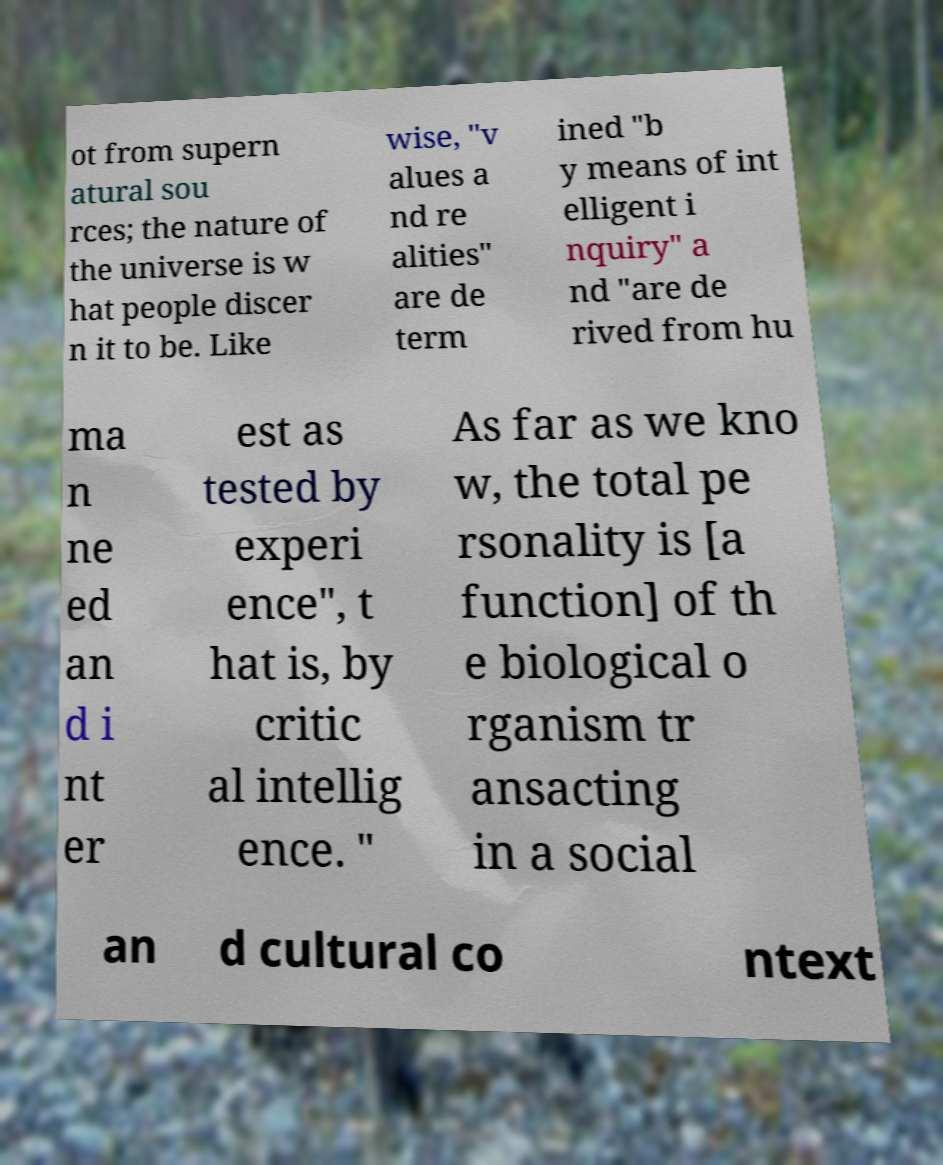What messages or text are displayed in this image? I need them in a readable, typed format. ot from supern atural sou rces; the nature of the universe is w hat people discer n it to be. Like wise, "v alues a nd re alities" are de term ined "b y means of int elligent i nquiry" a nd "are de rived from hu ma n ne ed an d i nt er est as tested by experi ence", t hat is, by critic al intellig ence. " As far as we kno w, the total pe rsonality is [a function] of th e biological o rganism tr ansacting in a social an d cultural co ntext 